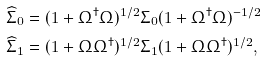Convert formula to latex. <formula><loc_0><loc_0><loc_500><loc_500>\widehat { \Sigma } _ { 0 } & = ( 1 + \Omega ^ { \dagger } \Omega ) ^ { 1 / 2 } \Sigma _ { 0 } ( 1 + \Omega ^ { \dagger } \Omega ) ^ { - 1 / 2 } \\ \widehat { \Sigma } _ { 1 } & = ( 1 + \Omega \Omega ^ { \dagger } ) ^ { 1 / 2 } \Sigma _ { 1 } ( 1 + \Omega \Omega ^ { \dagger } ) ^ { 1 / 2 } ,</formula> 